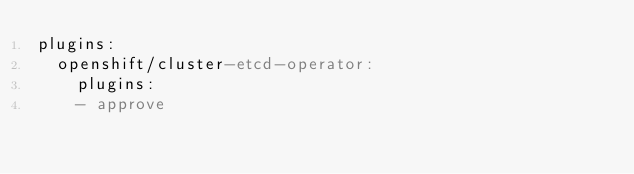<code> <loc_0><loc_0><loc_500><loc_500><_YAML_>plugins:
  openshift/cluster-etcd-operator:
    plugins:
    - approve
</code> 